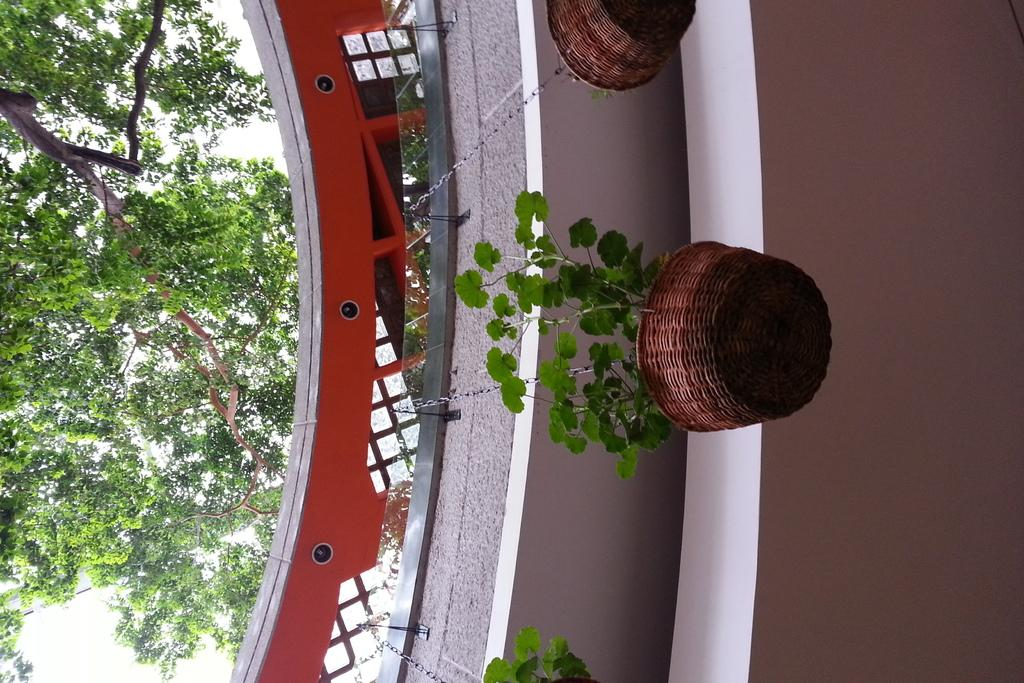What is hanging on the wall in the image? There are plants in a basket hanging on a wall in the image. What type of structure is depicted in the image? The image appears to be of a building. What can be seen on the right side of the image? There is a tree on the right side of the image. How is the image oriented? The image is inverted. Can you see any matches or carpenters in the image? There are no matches or carpenters present in the image. What type of transportation can be seen at the airport in the image? There is no airport or transportation depicted in the image. 